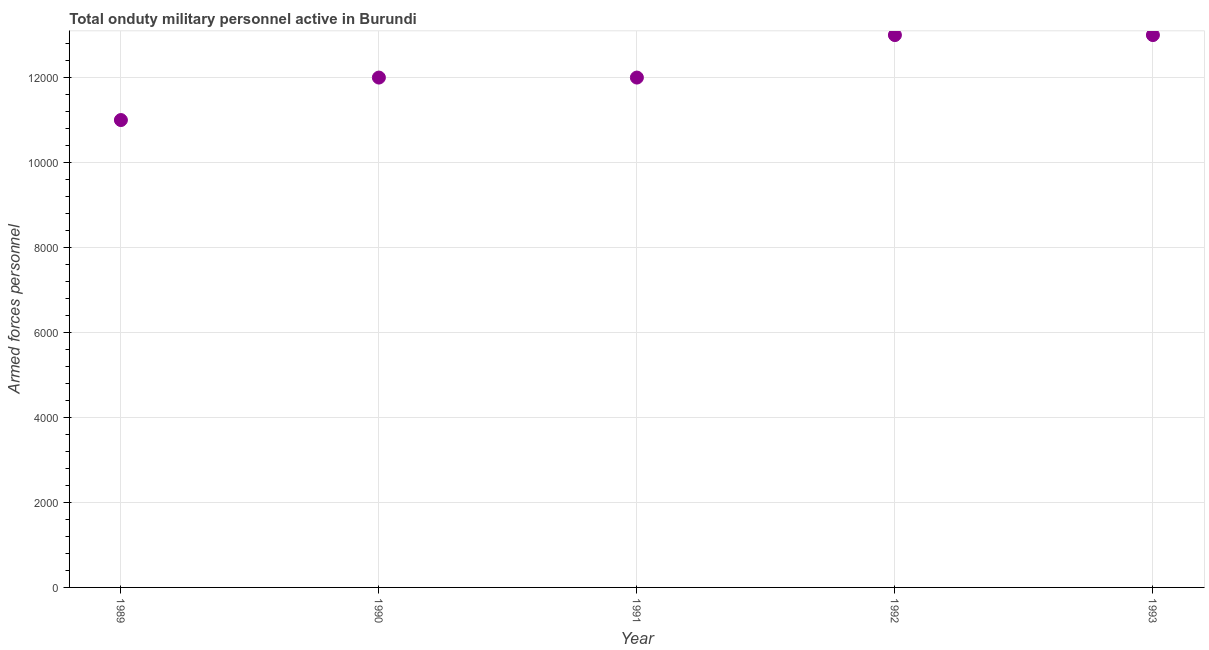What is the number of armed forces personnel in 1992?
Your answer should be compact. 1.30e+04. Across all years, what is the maximum number of armed forces personnel?
Provide a succinct answer. 1.30e+04. Across all years, what is the minimum number of armed forces personnel?
Ensure brevity in your answer.  1.10e+04. What is the sum of the number of armed forces personnel?
Provide a short and direct response. 6.10e+04. What is the difference between the number of armed forces personnel in 1989 and 1993?
Your answer should be compact. -2000. What is the average number of armed forces personnel per year?
Ensure brevity in your answer.  1.22e+04. What is the median number of armed forces personnel?
Make the answer very short. 1.20e+04. In how many years, is the number of armed forces personnel greater than 9600 ?
Make the answer very short. 5. Do a majority of the years between 1993 and 1990 (inclusive) have number of armed forces personnel greater than 9600 ?
Your response must be concise. Yes. What is the ratio of the number of armed forces personnel in 1991 to that in 1993?
Your answer should be very brief. 0.92. Is the sum of the number of armed forces personnel in 1990 and 1991 greater than the maximum number of armed forces personnel across all years?
Keep it short and to the point. Yes. Does the number of armed forces personnel monotonically increase over the years?
Offer a terse response. No. What is the difference between two consecutive major ticks on the Y-axis?
Offer a terse response. 2000. Are the values on the major ticks of Y-axis written in scientific E-notation?
Provide a succinct answer. No. Does the graph contain any zero values?
Your answer should be compact. No. Does the graph contain grids?
Keep it short and to the point. Yes. What is the title of the graph?
Provide a short and direct response. Total onduty military personnel active in Burundi. What is the label or title of the X-axis?
Give a very brief answer. Year. What is the label or title of the Y-axis?
Offer a very short reply. Armed forces personnel. What is the Armed forces personnel in 1989?
Ensure brevity in your answer.  1.10e+04. What is the Armed forces personnel in 1990?
Offer a very short reply. 1.20e+04. What is the Armed forces personnel in 1991?
Provide a succinct answer. 1.20e+04. What is the Armed forces personnel in 1992?
Your answer should be compact. 1.30e+04. What is the Armed forces personnel in 1993?
Give a very brief answer. 1.30e+04. What is the difference between the Armed forces personnel in 1989 and 1990?
Provide a short and direct response. -1000. What is the difference between the Armed forces personnel in 1989 and 1991?
Your response must be concise. -1000. What is the difference between the Armed forces personnel in 1989 and 1992?
Your response must be concise. -2000. What is the difference between the Armed forces personnel in 1989 and 1993?
Your answer should be compact. -2000. What is the difference between the Armed forces personnel in 1990 and 1992?
Provide a short and direct response. -1000. What is the difference between the Armed forces personnel in 1990 and 1993?
Your response must be concise. -1000. What is the difference between the Armed forces personnel in 1991 and 1992?
Offer a very short reply. -1000. What is the difference between the Armed forces personnel in 1991 and 1993?
Make the answer very short. -1000. What is the ratio of the Armed forces personnel in 1989 to that in 1990?
Provide a short and direct response. 0.92. What is the ratio of the Armed forces personnel in 1989 to that in 1991?
Offer a very short reply. 0.92. What is the ratio of the Armed forces personnel in 1989 to that in 1992?
Make the answer very short. 0.85. What is the ratio of the Armed forces personnel in 1989 to that in 1993?
Provide a short and direct response. 0.85. What is the ratio of the Armed forces personnel in 1990 to that in 1991?
Your answer should be compact. 1. What is the ratio of the Armed forces personnel in 1990 to that in 1992?
Keep it short and to the point. 0.92. What is the ratio of the Armed forces personnel in 1990 to that in 1993?
Keep it short and to the point. 0.92. What is the ratio of the Armed forces personnel in 1991 to that in 1992?
Ensure brevity in your answer.  0.92. What is the ratio of the Armed forces personnel in 1991 to that in 1993?
Offer a terse response. 0.92. 